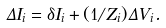<formula> <loc_0><loc_0><loc_500><loc_500>\Delta I _ { i } = \delta I _ { i } + ( 1 / Z _ { i } ) \Delta V _ { i } .</formula> 